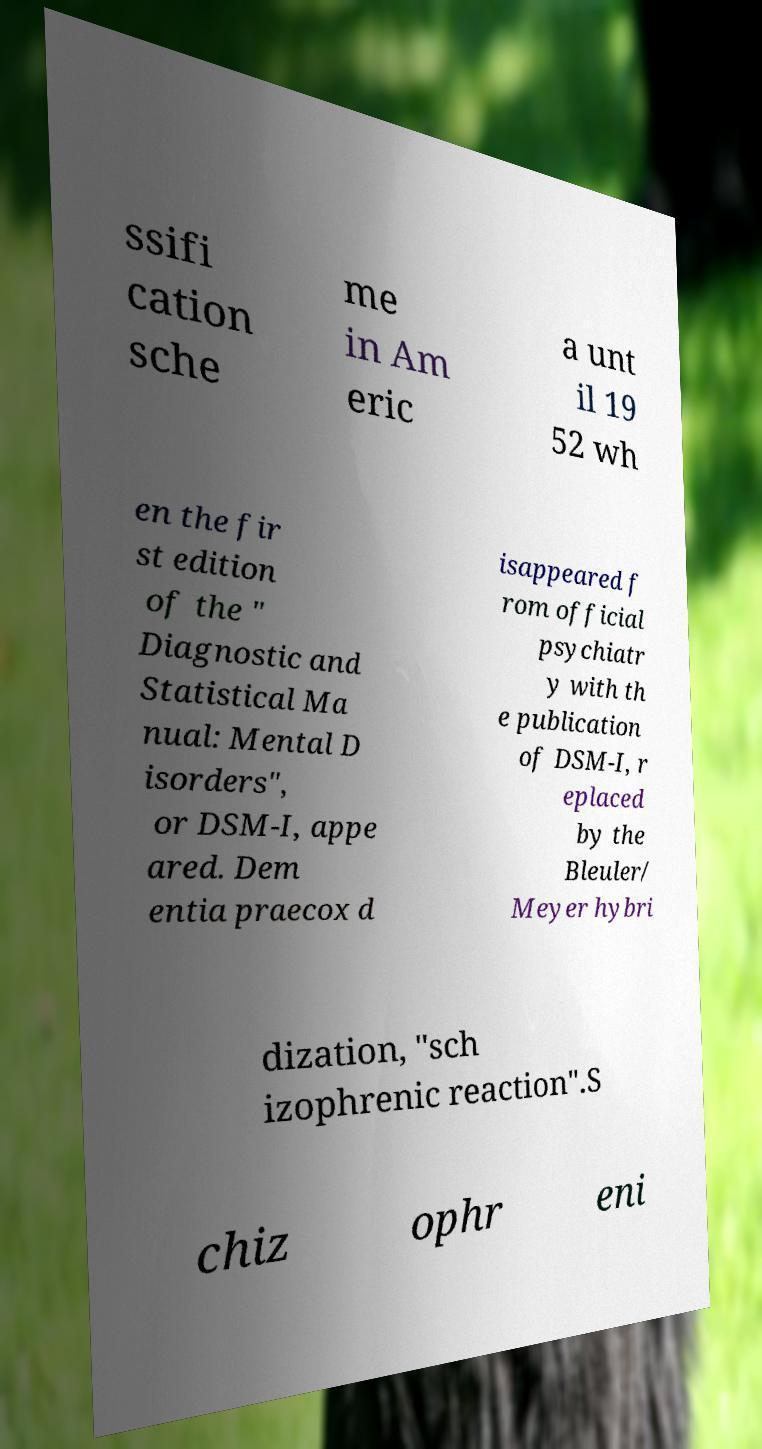I need the written content from this picture converted into text. Can you do that? ssifi cation sche me in Am eric a unt il 19 52 wh en the fir st edition of the " Diagnostic and Statistical Ma nual: Mental D isorders", or DSM-I, appe ared. Dem entia praecox d isappeared f rom official psychiatr y with th e publication of DSM-I, r eplaced by the Bleuler/ Meyer hybri dization, "sch izophrenic reaction".S chiz ophr eni 